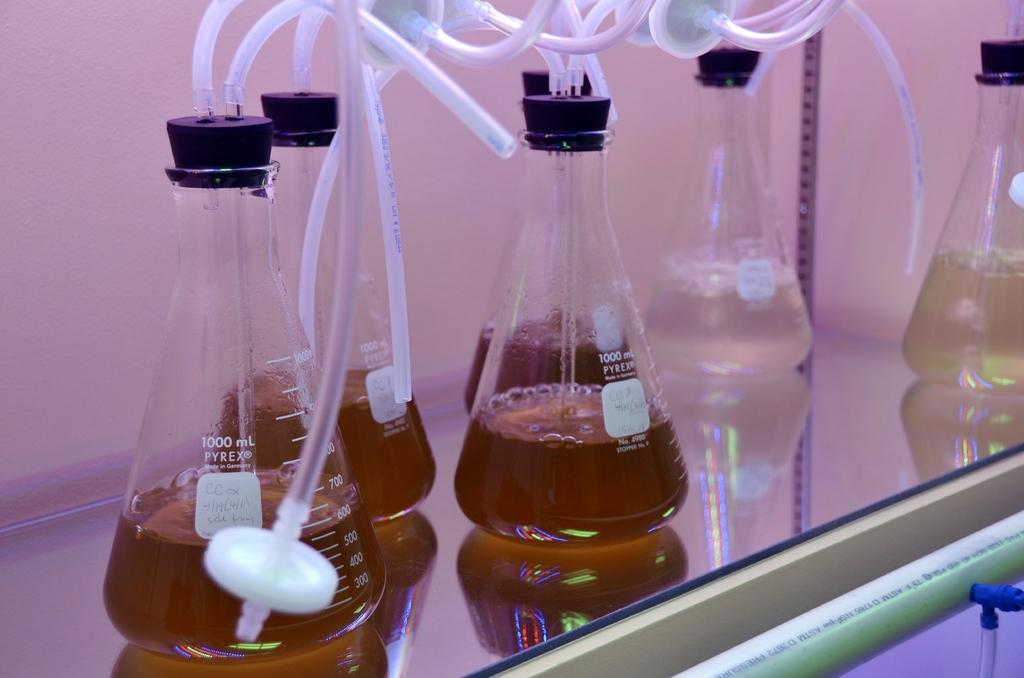How many ml does this hold?
Provide a short and direct response. 1000. What brand is the beaker?
Make the answer very short. Pyrex. 